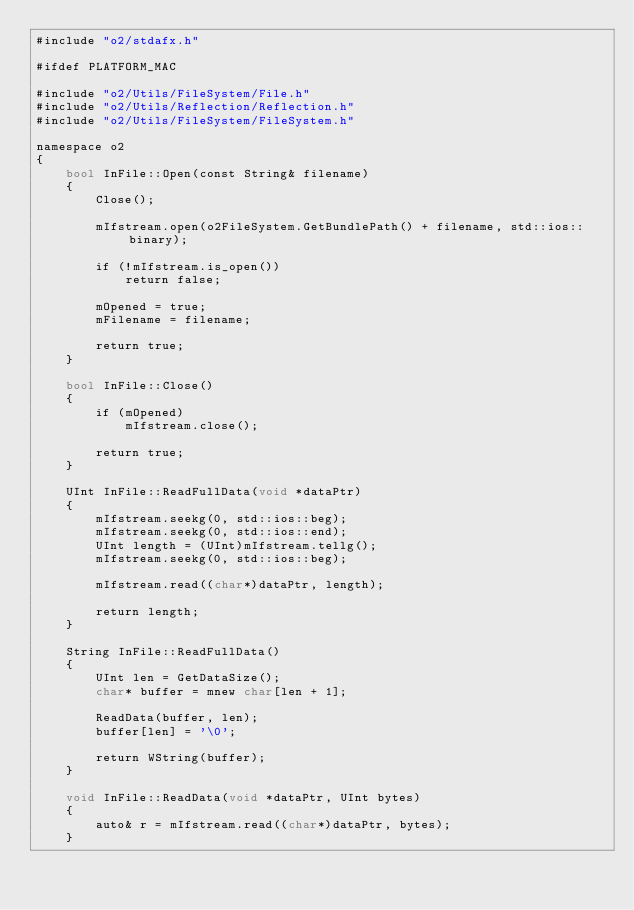Convert code to text. <code><loc_0><loc_0><loc_500><loc_500><_ObjectiveC_>#include "o2/stdafx.h"

#ifdef PLATFORM_MAC

#include "o2/Utils/FileSystem/File.h"
#include "o2/Utils/Reflection/Reflection.h"
#include "o2/Utils/FileSystem/FileSystem.h"

namespace o2
{
    bool InFile::Open(const String& filename)
    {
        Close();

        mIfstream.open(o2FileSystem.GetBundlePath() + filename, std::ios::binary);

        if (!mIfstream.is_open())
			return false;

        mOpened = true;
        mFilename = filename;

        return true;
    }

    bool InFile::Close()
    {
        if (mOpened)
            mIfstream.close();

        return true;
    }

    UInt InFile::ReadFullData(void *dataPtr)
    {
        mIfstream.seekg(0, std::ios::beg);
        mIfstream.seekg(0, std::ios::end);
        UInt length = (UInt)mIfstream.tellg();
        mIfstream.seekg(0, std::ios::beg);

        mIfstream.read((char*)dataPtr, length);

        return length;
    }

    String InFile::ReadFullData()
    {
        UInt len = GetDataSize();
        char* buffer = mnew char[len + 1];

        ReadData(buffer, len);
        buffer[len] = '\0';

		return WString(buffer);
    }

    void InFile::ReadData(void *dataPtr, UInt bytes)
    {
        auto& r = mIfstream.read((char*)dataPtr, bytes);
    }
</code> 